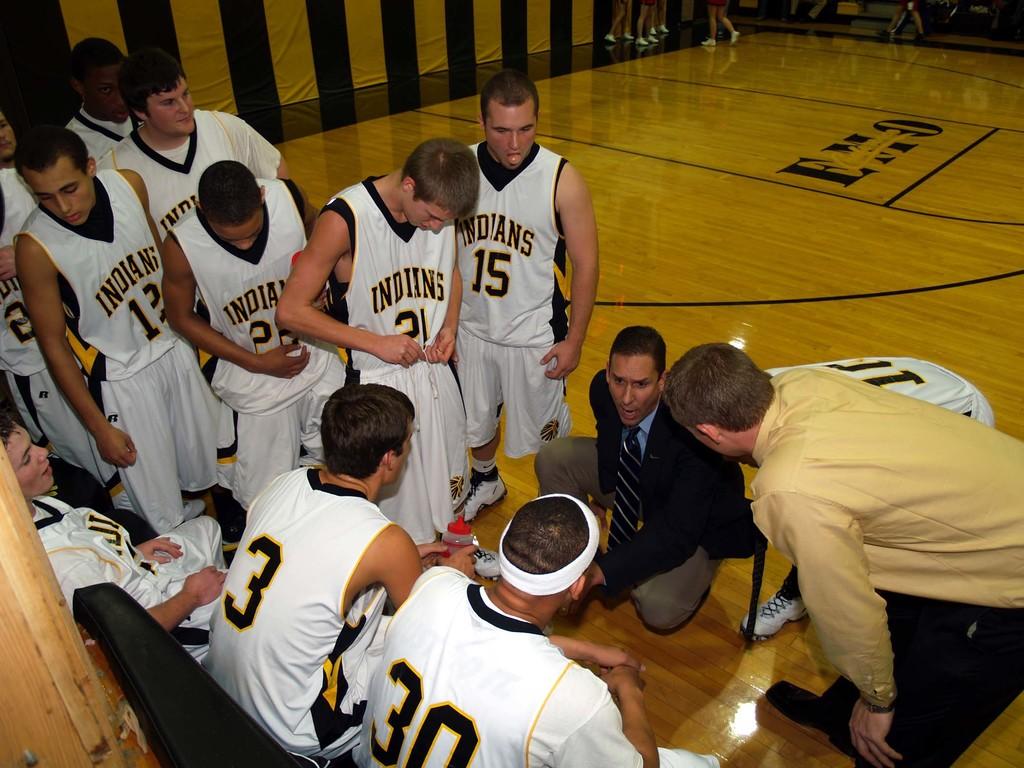What is the teams name?
Offer a terse response. Indians. The number closest to the front is?
Offer a terse response. 30. 